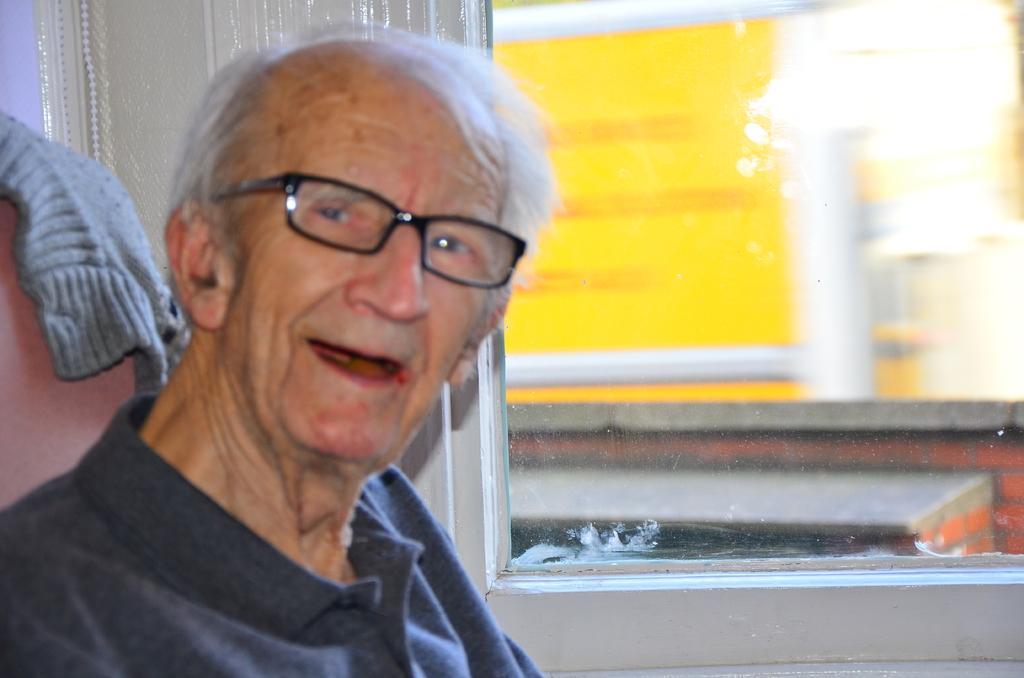Please provide a concise description of this image. In this image an old man is sitting on chair. He is smiling. In the background there is glass window. Through which we can see outside buildings. 